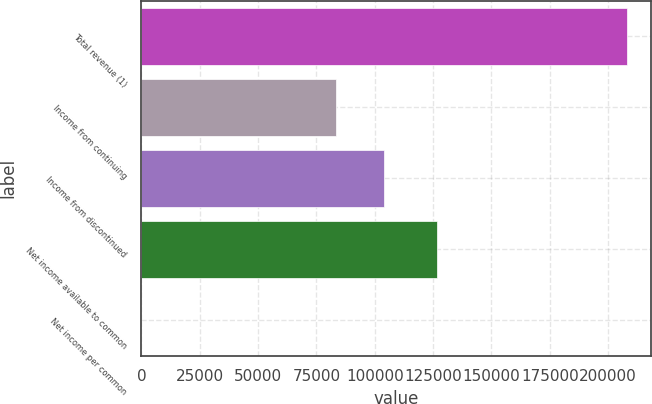<chart> <loc_0><loc_0><loc_500><loc_500><bar_chart><fcel>Total revenue (1)<fcel>Income from continuing<fcel>Income from discontinued<fcel>Net income available to common<fcel>Net income per common<nl><fcel>208123<fcel>83249.5<fcel>104062<fcel>126594<fcel>0.53<nl></chart> 